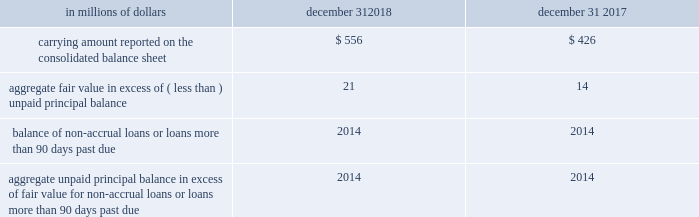Changes in the fair value of funded and unfunded credit products are classified in principal transactions in citi 2019s consolidated statement of income .
Related interest revenue is measured based on the contractual interest rates and reported as interest revenue on trading account assets or loan interest depending on the balance sheet classifications of the credit products .
The changes in fair value for the years ended december 31 , 2018 and 2017 due to instrument-specific credit risk totaled to a loss of $ 27 million and a gain of $ 10 million , respectively .
Certain investments in unallocated precious metals citigroup invests in unallocated precious metals accounts ( gold , silver , platinum and palladium ) as part of its commodity and foreign currency trading activities or to economically hedge certain exposures from issuing structured liabilities .
Under asc 815 , the investment is bifurcated into a debt host contract and a commodity forward derivative instrument .
Citigroup elects the fair value option for the debt host contract , and reports the debt host contract within trading account assets on the company 2019s consolidated balance sheet .
The total carrying amount of debt host contracts across unallocated precious metals accounts was approximately $ 0.4 billion and $ 0.9 billion at december 31 , 2018 and 2017 , respectively .
The amounts are expected to fluctuate based on trading activity in future periods .
As part of its commodity and foreign currency trading activities , citi trades unallocated precious metals investments and executes forward purchase and forward sale derivative contracts with trading counterparties .
When citi sells an unallocated precious metals investment , citi 2019s receivable from its depository bank is repaid and citi derecognizes its investment in the unallocated precious metal .
The forward purchase or sale contract with the trading counterparty indexed to unallocated precious metals is accounted for as a derivative , at fair value through earnings .
As of december 31 , 2018 , there were approximately $ 13.7 billion and $ 10.3 billion in notional amounts of such forward purchase and forward sale derivative contracts outstanding , respectively .
Certain investments in private equity and real estate ventures and certain equity method and other investments citigroup invests in private equity and real estate ventures for the purpose of earning investment returns and for capital appreciation .
The company has elected the fair value option for certain of these ventures , because such investments are considered similar to many private equity or hedge fund activities in citi 2019s investment companies , which are reported at fair value .
The fair value option brings consistency in the accounting and evaluation of these investments .
All investments ( debt and equity ) in such private equity and real estate entities are accounted for at fair value .
These investments are classified as investments on citigroup 2019s consolidated balance sheet .
Changes in the fair values of these investments are classified in other revenue in the company 2019s consolidated statement of income .
Citigroup also elected the fair value option for certain non-marketable equity securities whose risk is managed with derivative instruments that are accounted for at fair value through earnings .
These securities are classified as trading account assets on citigroup 2019s consolidated balance sheet .
Changes in the fair value of these securities and the related derivative instruments are recorded in principal transactions .
Effective january 1 , 2018 under asu 2016-01 and asu 2018-03 , a fair value option election is no longer required to measure these non-marketable equity securities through earnings .
See note 1 to the consolidated financial statements for additional details .
Certain mortgage loans held-for-sale citigroup has elected the fair value option for certain purchased and originated prime fixed-rate and conforming adjustable-rate first mortgage loans hfs .
These loans are intended for sale or securitization and are hedged with derivative instruments .
The company has elected the fair value option to mitigate accounting mismatches in cases where hedge accounting is complex and to achieve operational simplifications .
The table provides information about certain mortgage loans hfs carried at fair value: .
The changes in the fair values of these mortgage loans are reported in other revenue in the company 2019s consolidated statement of income .
There was no net change in fair value during the years ended december 31 , 2018 and 2017 due to instrument-specific credit risk .
Related interest income continues to be measured based on the contractual interest rates and reported as interest revenue in the consolidated statement of income. .
What was the change in millions in the carrying amount reported on the consolidate balance sheet from 2017 to 2018? 
Computations: (556 - 426)
Answer: 130.0. Changes in the fair value of funded and unfunded credit products are classified in principal transactions in citi 2019s consolidated statement of income .
Related interest revenue is measured based on the contractual interest rates and reported as interest revenue on trading account assets or loan interest depending on the balance sheet classifications of the credit products .
The changes in fair value for the years ended december 31 , 2018 and 2017 due to instrument-specific credit risk totaled to a loss of $ 27 million and a gain of $ 10 million , respectively .
Certain investments in unallocated precious metals citigroup invests in unallocated precious metals accounts ( gold , silver , platinum and palladium ) as part of its commodity and foreign currency trading activities or to economically hedge certain exposures from issuing structured liabilities .
Under asc 815 , the investment is bifurcated into a debt host contract and a commodity forward derivative instrument .
Citigroup elects the fair value option for the debt host contract , and reports the debt host contract within trading account assets on the company 2019s consolidated balance sheet .
The total carrying amount of debt host contracts across unallocated precious metals accounts was approximately $ 0.4 billion and $ 0.9 billion at december 31 , 2018 and 2017 , respectively .
The amounts are expected to fluctuate based on trading activity in future periods .
As part of its commodity and foreign currency trading activities , citi trades unallocated precious metals investments and executes forward purchase and forward sale derivative contracts with trading counterparties .
When citi sells an unallocated precious metals investment , citi 2019s receivable from its depository bank is repaid and citi derecognizes its investment in the unallocated precious metal .
The forward purchase or sale contract with the trading counterparty indexed to unallocated precious metals is accounted for as a derivative , at fair value through earnings .
As of december 31 , 2018 , there were approximately $ 13.7 billion and $ 10.3 billion in notional amounts of such forward purchase and forward sale derivative contracts outstanding , respectively .
Certain investments in private equity and real estate ventures and certain equity method and other investments citigroup invests in private equity and real estate ventures for the purpose of earning investment returns and for capital appreciation .
The company has elected the fair value option for certain of these ventures , because such investments are considered similar to many private equity or hedge fund activities in citi 2019s investment companies , which are reported at fair value .
The fair value option brings consistency in the accounting and evaluation of these investments .
All investments ( debt and equity ) in such private equity and real estate entities are accounted for at fair value .
These investments are classified as investments on citigroup 2019s consolidated balance sheet .
Changes in the fair values of these investments are classified in other revenue in the company 2019s consolidated statement of income .
Citigroup also elected the fair value option for certain non-marketable equity securities whose risk is managed with derivative instruments that are accounted for at fair value through earnings .
These securities are classified as trading account assets on citigroup 2019s consolidated balance sheet .
Changes in the fair value of these securities and the related derivative instruments are recorded in principal transactions .
Effective january 1 , 2018 under asu 2016-01 and asu 2018-03 , a fair value option election is no longer required to measure these non-marketable equity securities through earnings .
See note 1 to the consolidated financial statements for additional details .
Certain mortgage loans held-for-sale citigroup has elected the fair value option for certain purchased and originated prime fixed-rate and conforming adjustable-rate first mortgage loans hfs .
These loans are intended for sale or securitization and are hedged with derivative instruments .
The company has elected the fair value option to mitigate accounting mismatches in cases where hedge accounting is complex and to achieve operational simplifications .
The table provides information about certain mortgage loans hfs carried at fair value: .
The changes in the fair values of these mortgage loans are reported in other revenue in the company 2019s consolidated statement of income .
There was no net change in fair value during the years ended december 31 , 2018 and 2017 due to instrument-specific credit risk .
Related interest income continues to be measured based on the contractual interest rates and reported as interest revenue in the consolidated statement of income. .
What was the percentage change in the carrying amount reported on the consolidate balance sheet from 2017 to 2018? 
Computations: ((556 - 426) / 426)
Answer: 0.30516. 